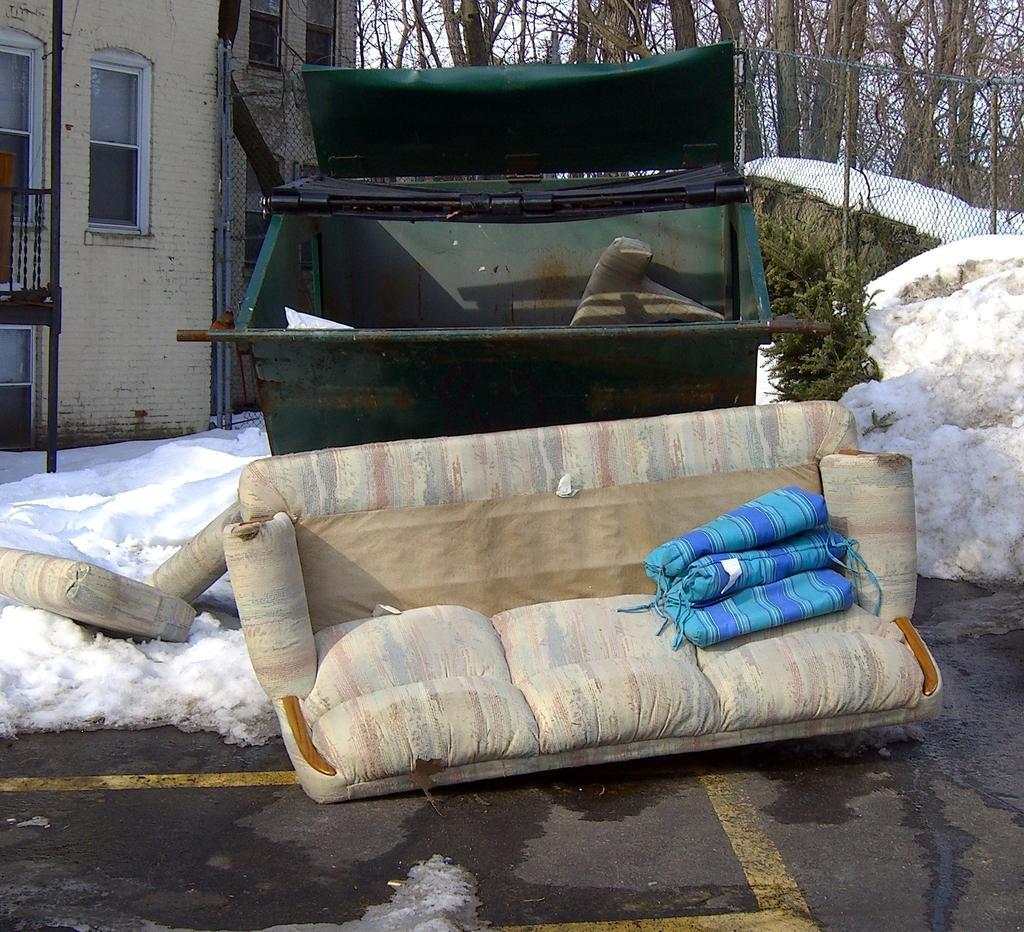In one or two sentences, can you explain what this image depicts? In this image we can see a dustbin. Near to that there is a sofa. Also there are pillows. And there is snow. On the left side there is a building with windows. In the background there are trees. And there is a mesh fencing. 